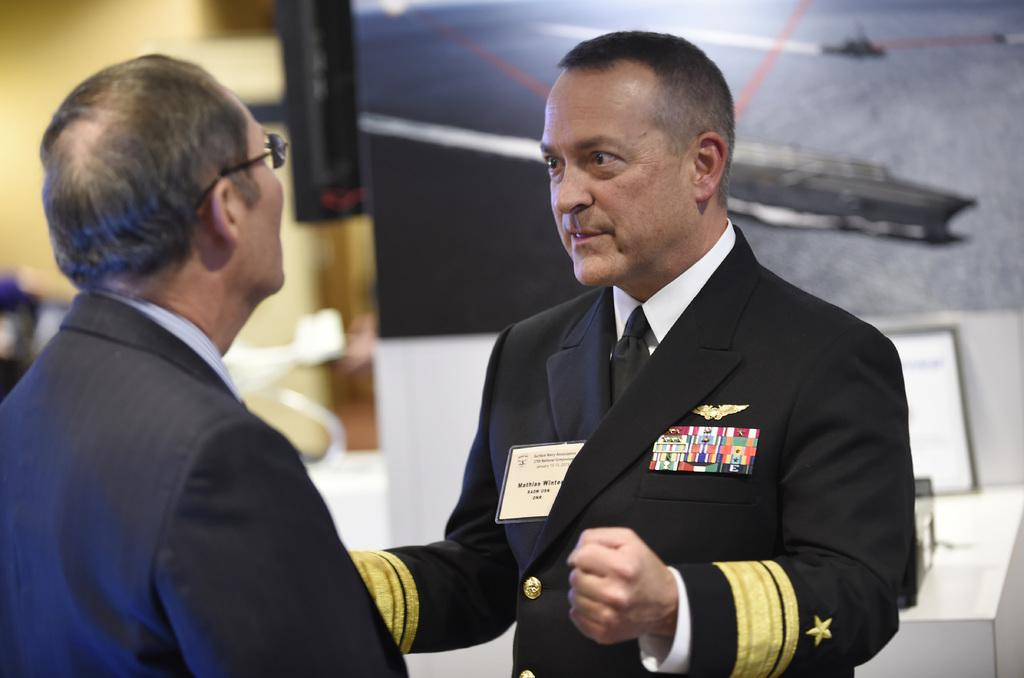How many people are in the image? There are two people in the image. What are the people wearing? The people are wearing suits. What can be seen in the background of the image? There is a board in the background of the image. What color is the background surface? The background surface is white. What is the rate at which the crow is flying in the image? There is no crow present in the image, so it is not possible to determine the rate at which it might be flying. 